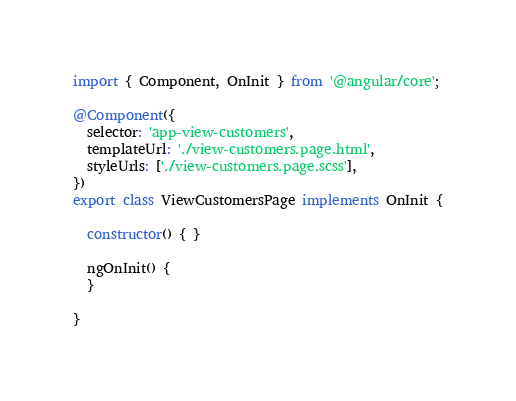<code> <loc_0><loc_0><loc_500><loc_500><_TypeScript_>import { Component, OnInit } from '@angular/core';

@Component({
  selector: 'app-view-customers',
  templateUrl: './view-customers.page.html',
  styleUrls: ['./view-customers.page.scss'],
})
export class ViewCustomersPage implements OnInit {

  constructor() { }

  ngOnInit() {
  }

}
</code> 